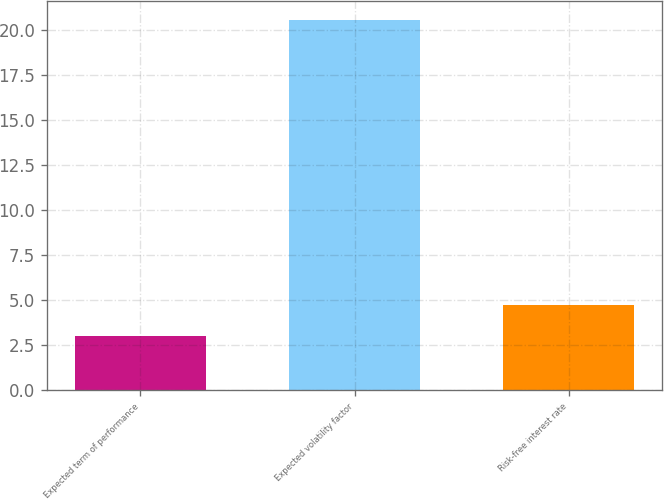<chart> <loc_0><loc_0><loc_500><loc_500><bar_chart><fcel>Expected term of performance<fcel>Expected volatility factor<fcel>Risk-free interest rate<nl><fcel>3<fcel>20.54<fcel>4.75<nl></chart> 